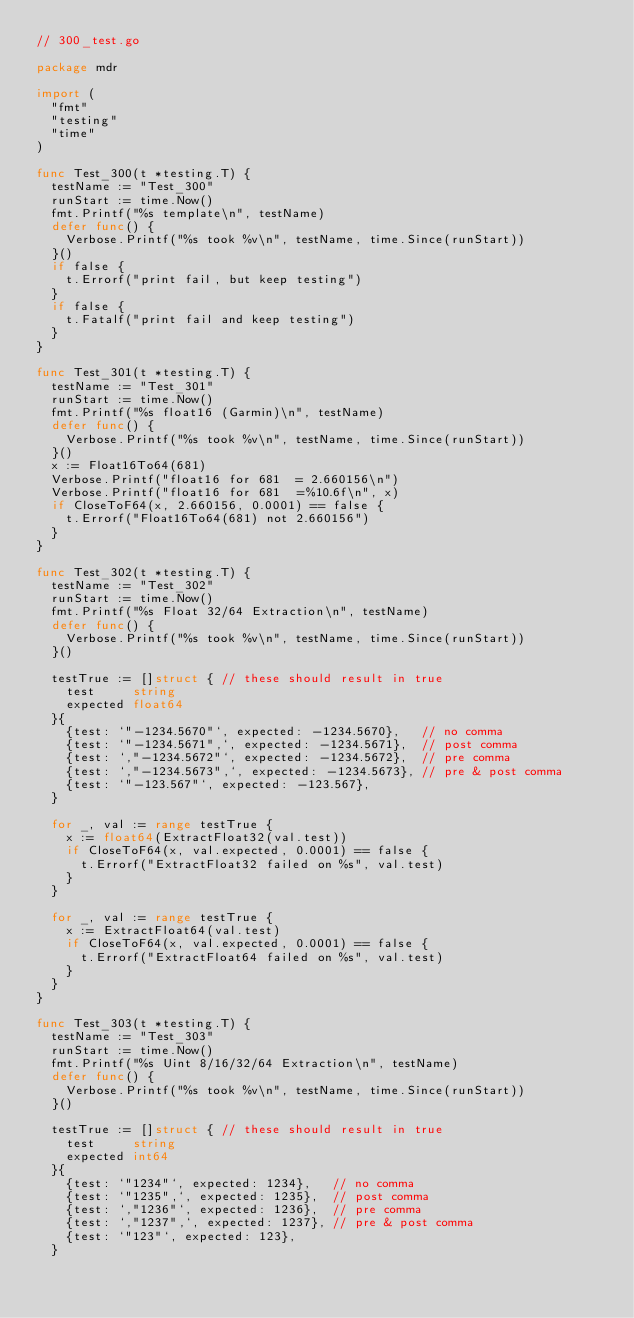Convert code to text. <code><loc_0><loc_0><loc_500><loc_500><_Go_>// 300_test.go

package mdr

import (
	"fmt"
	"testing"
	"time"
)

func Test_300(t *testing.T) {
	testName := "Test_300"
	runStart := time.Now()
	fmt.Printf("%s template\n", testName)
	defer func() {
		Verbose.Printf("%s took %v\n", testName, time.Since(runStart))
	}()
	if false {
		t.Errorf("print fail, but keep testing")
	}
	if false {
		t.Fatalf("print fail and keep testing")
	}
}

func Test_301(t *testing.T) {
	testName := "Test_301"
	runStart := time.Now()
	fmt.Printf("%s float16 (Garmin)\n", testName)
	defer func() {
		Verbose.Printf("%s took %v\n", testName, time.Since(runStart))
	}()
	x := Float16To64(681)
	Verbose.Printf("float16 for 681  = 2.660156\n")
	Verbose.Printf("float16 for 681  =%10.6f\n", x)
	if CloseToF64(x, 2.660156, 0.0001) == false {
		t.Errorf("Float16To64(681) not 2.660156")
	}
}

func Test_302(t *testing.T) {
	testName := "Test_302"
	runStart := time.Now()
	fmt.Printf("%s Float 32/64 Extraction\n", testName)
	defer func() {
		Verbose.Printf("%s took %v\n", testName, time.Since(runStart))
	}()

	testTrue := []struct { // these should result in true
		test     string
		expected float64
	}{
		{test: `"-1234.5670"`, expected: -1234.5670},   // no comma
		{test: `"-1234.5671",`, expected: -1234.5671},  // post comma
		{test: `,"-1234.5672"`, expected: -1234.5672},  // pre comma
		{test: `,"-1234.5673",`, expected: -1234.5673}, // pre & post comma
		{test: `"-123.567"`, expected: -123.567},
	}

	for _, val := range testTrue {
		x := float64(ExtractFloat32(val.test))
		if CloseToF64(x, val.expected, 0.0001) == false {
			t.Errorf("ExtractFloat32 failed on %s", val.test)
		}
	}

	for _, val := range testTrue {
		x := ExtractFloat64(val.test)
		if CloseToF64(x, val.expected, 0.0001) == false {
			t.Errorf("ExtractFloat64 failed on %s", val.test)
		}
	}
}

func Test_303(t *testing.T) {
	testName := "Test_303"
	runStart := time.Now()
	fmt.Printf("%s Uint 8/16/32/64 Extraction\n", testName)
	defer func() {
		Verbose.Printf("%s took %v\n", testName, time.Since(runStart))
	}()

	testTrue := []struct { // these should result in true
		test     string
		expected int64
	}{
		{test: `"1234"`, expected: 1234},   // no comma
		{test: `"1235",`, expected: 1235},  // post comma
		{test: `,"1236"`, expected: 1236},  // pre comma
		{test: `,"1237",`, expected: 1237}, // pre & post comma
		{test: `"123"`, expected: 123},
	}
</code> 